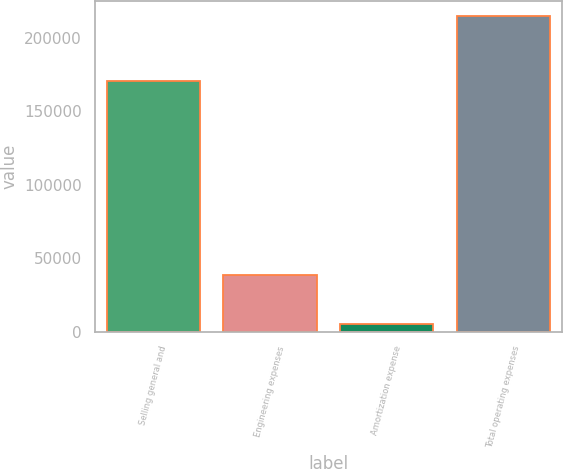<chart> <loc_0><loc_0><loc_500><loc_500><bar_chart><fcel>Selling general and<fcel>Engineering expenses<fcel>Amortization expense<fcel>Total operating expenses<nl><fcel>170597<fcel>38981<fcel>5092<fcel>214670<nl></chart> 